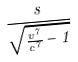Convert formula to latex. <formula><loc_0><loc_0><loc_500><loc_500>\frac { s } { \sqrt { \frac { v ^ { 7 } } { c ^ { 7 } } - 1 } }</formula> 